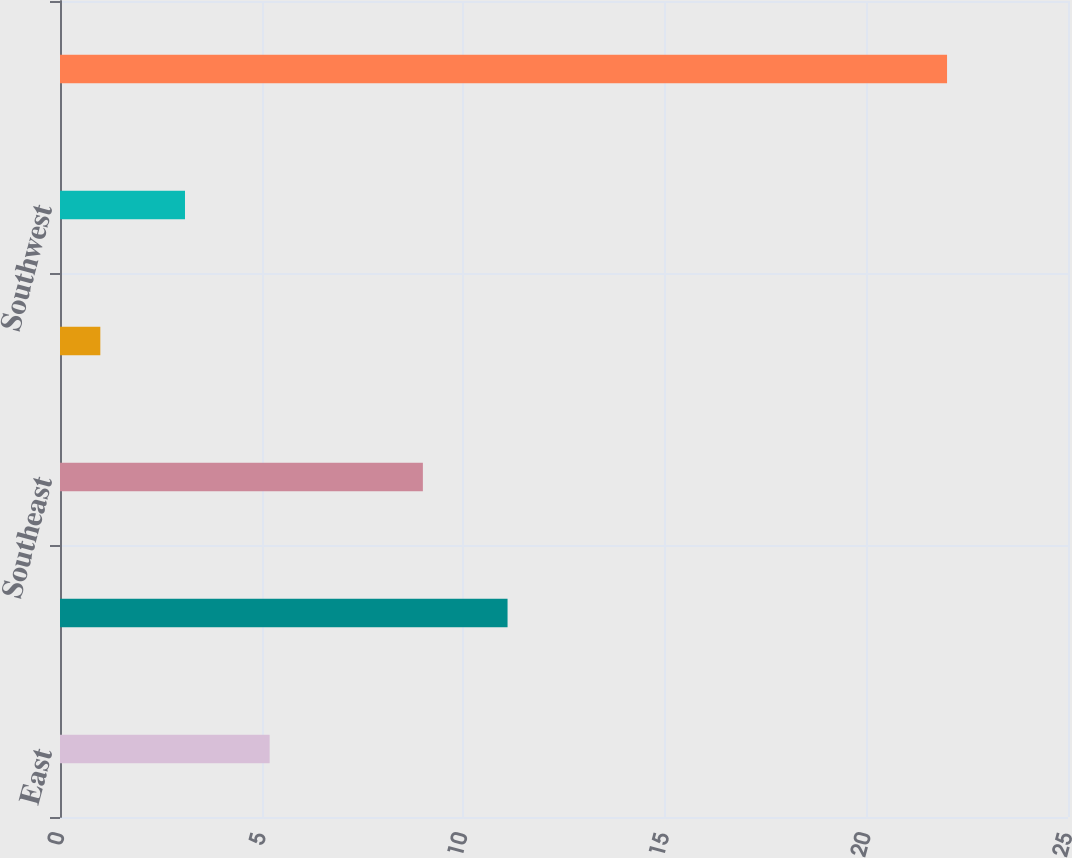<chart> <loc_0><loc_0><loc_500><loc_500><bar_chart><fcel>East<fcel>Midwest<fcel>Southeast<fcel>South Central<fcel>Southwest<fcel>West<nl><fcel>5.2<fcel>11.1<fcel>9<fcel>1<fcel>3.1<fcel>22<nl></chart> 